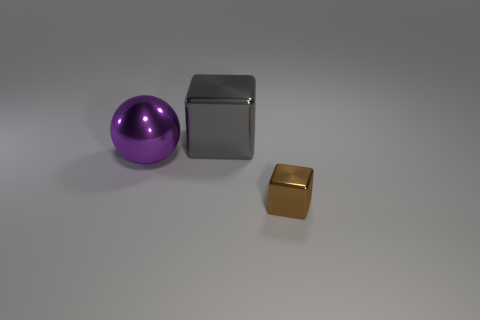Add 2 gray objects. How many objects exist? 5 Subtract 0 green spheres. How many objects are left? 3 Subtract all cubes. How many objects are left? 1 Subtract 1 blocks. How many blocks are left? 1 Subtract all purple blocks. Subtract all green balls. How many blocks are left? 2 Subtract all green cylinders. How many gray blocks are left? 1 Subtract all large blue matte cylinders. Subtract all big blocks. How many objects are left? 2 Add 2 tiny brown objects. How many tiny brown objects are left? 3 Add 3 tiny metal blocks. How many tiny metal blocks exist? 4 